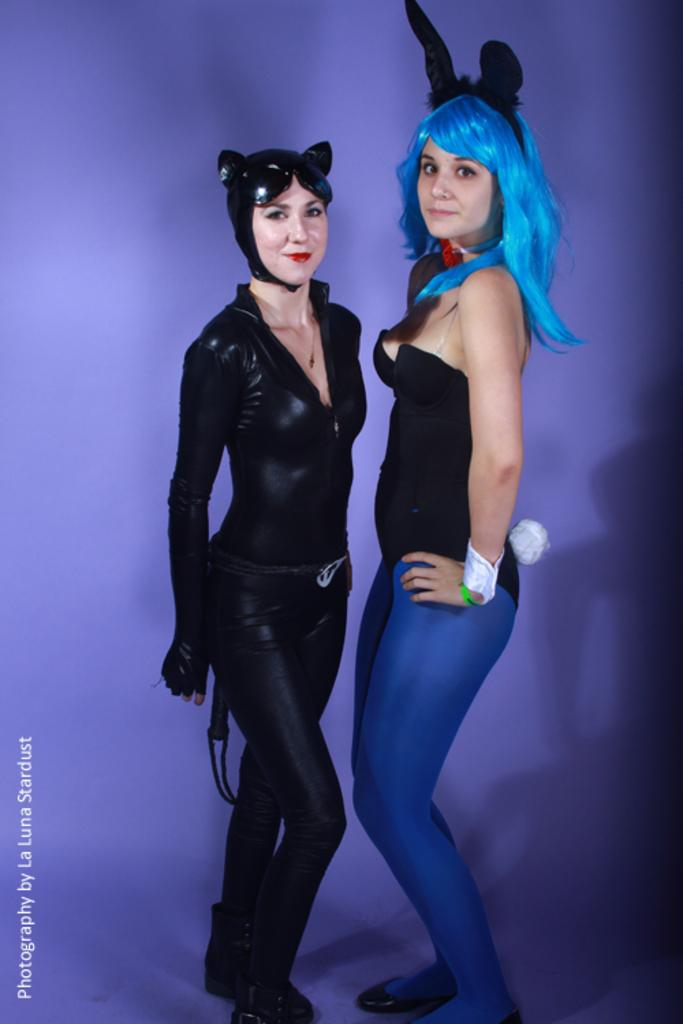How many people are present in the image? There are two ladies standing in the center of the image. What are the ladies wearing in the image? Both ladies are wearing costumes. Can you describe the crowd of people in the image? There is no crowd of people present in the image; it only features two ladies. What type of wave can be seen in the image? There is no wave present in the image. 